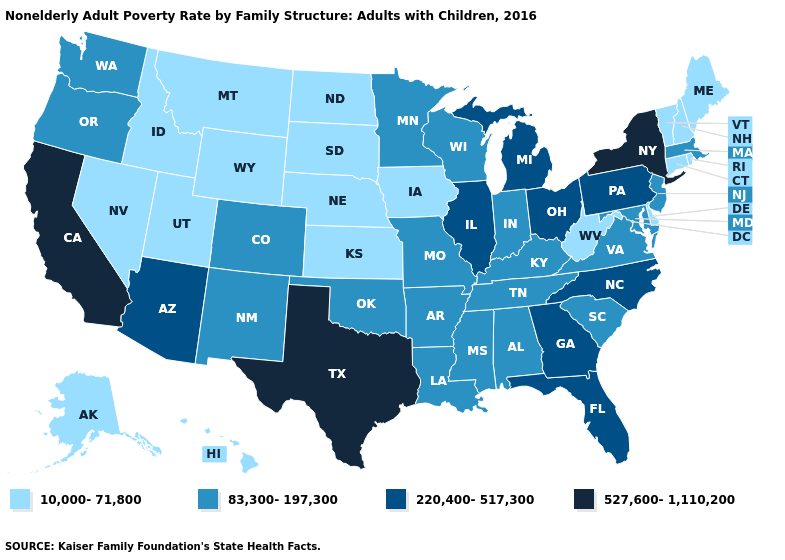What is the value of Michigan?
Answer briefly. 220,400-517,300. What is the lowest value in the Northeast?
Keep it brief. 10,000-71,800. Name the states that have a value in the range 527,600-1,110,200?
Write a very short answer. California, New York, Texas. Among the states that border Vermont , does New York have the lowest value?
Write a very short answer. No. Does New Jersey have the lowest value in the Northeast?
Concise answer only. No. What is the value of Delaware?
Short answer required. 10,000-71,800. What is the highest value in the USA?
Answer briefly. 527,600-1,110,200. Which states have the highest value in the USA?
Write a very short answer. California, New York, Texas. What is the lowest value in states that border Delaware?
Answer briefly. 83,300-197,300. Is the legend a continuous bar?
Be succinct. No. Among the states that border Florida , does Georgia have the highest value?
Answer briefly. Yes. Does Nebraska have the lowest value in the MidWest?
Keep it brief. Yes. Name the states that have a value in the range 220,400-517,300?
Write a very short answer. Arizona, Florida, Georgia, Illinois, Michigan, North Carolina, Ohio, Pennsylvania. What is the lowest value in states that border Nebraska?
Be succinct. 10,000-71,800. 